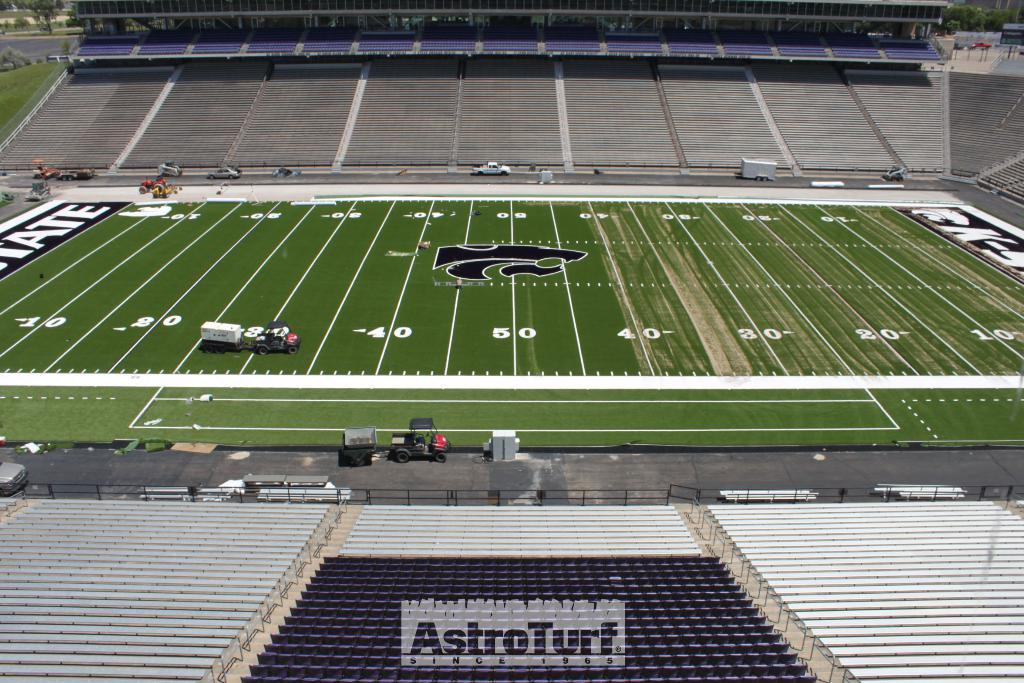What types of vehicles can be seen in the image? There are vehicles in the image, but the specific types are not mentioned. What type of terrain is visible in the image? There is grass visible in the image. What markings are present on the ground in the image? There are numbers on the ground in the image. What type of seating is present in the image? Stadium seating is present in the image. What type of barrier is present in the image? There is a fence in the image. What type of vegetation is visible at the top of the image? Trees are visible at the top of the image. What type of quilt is draped over the stadium seating in the image? There is no quilt present in the image; the stadium seating is empty. How does the sock react to the presence of the vehicles in the image? There is no sock present in the image, so it cannot react to anything. 